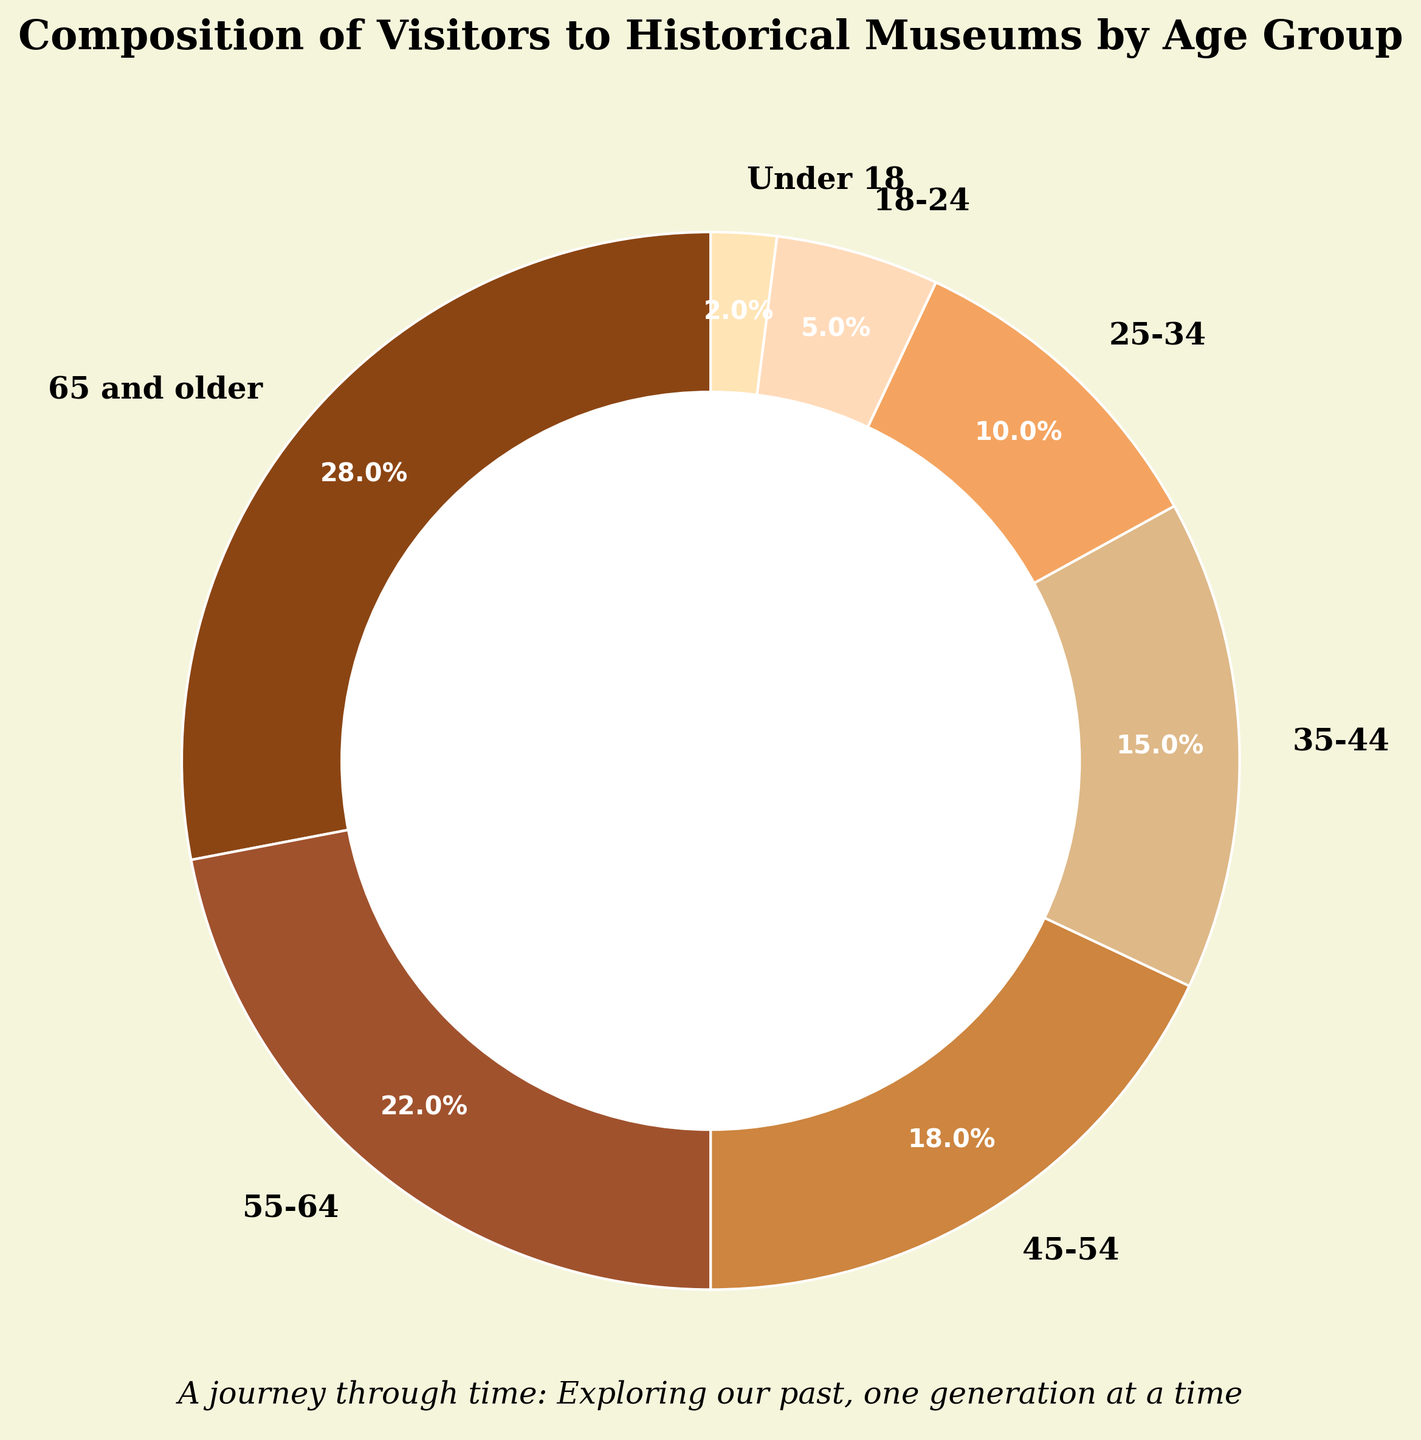Which age group has the highest percentage of visitors to historical museums? By looking at the pie chart and observing the labels and corresponding percentages, the age group 65 and older has the highest percentage at 28%.
Answer: 65 and older Which age group has the lowest percentage of visitors to historical museums? By examining the pie chart and the percentages associated with each age group, the Under 18 group has the lowest percentage at 2%.
Answer: Under 18 How much more percentage of visitors are in the 65 and older group compared to the 18-24 group? From the pie chart, the percentage of the 65 and older group is 28%. The percentage of the 18-24 group is 5%. The difference is calculated as 28% - 5% = 23%.
Answer: 23% What is the combined percentage of visitors aged 55-64 and 45-54? The chart shows that 55-64 is 22% and 45-54 is 18%. Summing these percentages gives 22% + 18% = 40%.
Answer: 40% Which age group is represented by the darkest color wedge in the pie chart? On the pie chart, the darkest color wedge corresponds to the 65 and older age group, indicating it has the highest percentage.
Answer: 65 and older How many age groups have a percentage greater than 20%? Referring to the pie chart, the age groups 65 and older (28%) and 55-64 (22%) have percentages greater than 20%. This makes a total of 2 age groups.
Answer: 2 What is the difference between the combined percentage of the 18-24 and Under 18 groups compared to the 35-44 group? Adding the percentages of 18-24 (5%) and Under 18 (2%) gives 7%. The percentage for 35-44 is 15%. The difference is 15% - 7% = 8%.
Answer: 8% Which two adjacent age groups combined have a percentage closest to 33%? Finding adjacent groups: 65+28%, 55-64+22%, 45-54+18%, 35-44+15%, 25-34+10%, 18-24+5%, Under 18+2%. Checking combinations: 35-44 + 25-34 = 25%, 25-34 + 18-24 = 15%, 55-64 + 45-54 = 40%, and others. The closest to 33% is 45-54 + 35-44 = 33%.
Answer: 45-54 and 35-44 What is the average percentage of visitors for age groups younger than 35? The chart shows three groups younger than 35: 25-34 (10%), 18-24 (5%), and Under 18 (2%). Average = (10% + 5% + 2%)/3 ≈ 5.67%.
Answer: 5.67% How does the percentage of visitors in the 25-34 group compare to the 55-64 group? The 25-34 group has a percentage of 10% while the 55-64 group has 22%, indicating that the 55-64 group has more than double the percentage of visitors.
Answer: 55-64 has more 